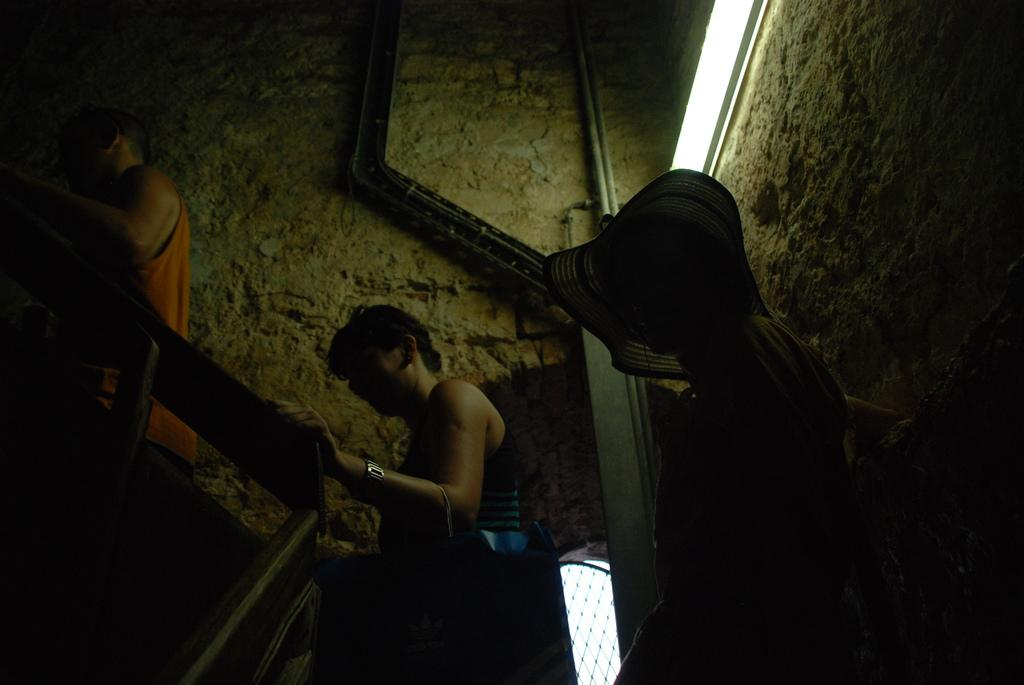What are the people in the image doing? The people in the image are climbing stairs. What feature is present along the side of the staircase? There is a staircase railing in the image. What can be seen in the background of the image? There is a wall in the background of the image. What type of infrastructure is visible in the image? There are pipes in the image. How does the taste of the visitor change after climbing the stairs in the image? There is no visitor present in the image, and therefore no taste to change. 